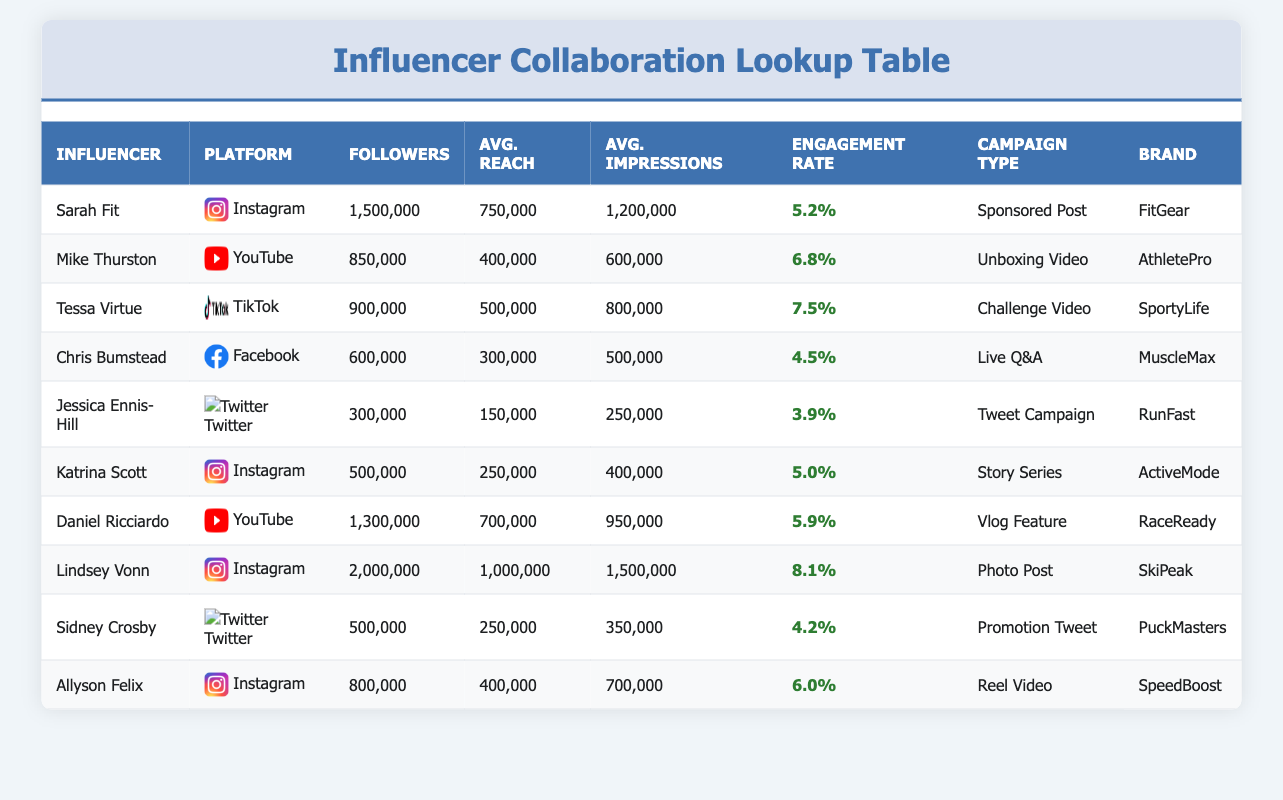What is the engagement rate of Sarah Fit? The engagement rate for Sarah Fit is listed directly in the table under the "Engagement Rate" column, showing 5.2%.
Answer: 5.2% Which influencer has the highest average impressions? By comparing the values in the "Avg. Impressions" column, Lindsey Vonn has the highest average impressions at 1,500,000.
Answer: 1,500,000 How many followers do all influencers combined have? The total number of followers can be calculated by adding up the values in the "Followers" column: 1,500,000 + 850,000 + 900,000 + 600,000 + 300,000 + 500,000 + 1,300,000 + 2,000,000 + 500,000 + 800,000 = 9,800,000. The sum is 9,800,000.
Answer: 9,800,000 Is Mike Thurston's engagement rate higher than Jessica Ennis-Hill's? Mike Thurston's engagement rate is 6.8%, while Jessica Ennis-Hill's engagement rate is 3.9%. Since 6.8% is greater than 3.9%, the answer is yes.
Answer: Yes What is the average reach of Instagram influencers based on this data? First, identify all influencers on Instagram: Sarah Fit, Katrina Scott, and Lindsey Vonn. Their average reach values are 750,000, 250,000, and 1,000,000, respectively. Sum these reach values: 750,000 + 250,000 + 1,000,000 = 2,000,000. There are 3 influencers, so divide by 3: 2,000,000 / 3 = 666,667.
Answer: 666,667 Which campaign type had the highest average reach, and what was the value? Calculate the average reach for each campaign type, looking at the corresponding values in the "Avg. Reach" column. The campaign types include: Sponsored Post (750,000), Unboxing Video (400,000), Challenge Video (500,000), Live Q&A (300,000), Tweet Campaign (150,000), Story Series (250,000), Vlog Feature (700,000), Photo Post (1,000,000), Promotion Tweet (250,000), and Reel Video (400,000). The highest average reach is from the Photo Post campaign type at 1,000,000.
Answer: Photo Post, 1,000,000 How many influencers have an engagement rate above 6%? Checking each influencer's engagement rate, we have: Sarah Fit (5.2%), Mike Thurston (6.8%), Tessa Virtue (7.5%), Chris Bumstead (4.5%), Jessica Ennis-Hill (3.9%), Katrina Scott (5.0%), Daniel Ricciardo (5.9%), Lindsey Vonn (8.1%), Sidney Crosby (4.2%), and Allyson Felix (6.0%). The influencers above 6% are Mike Thurston, Tessa Virtue, and Lindsey Vonn, totaling 3 influencers.
Answer: 3 Is the average impressions for "Live Q&A" higher than that for "Reel Video"? The average impressions for Live Q&A is 500,000, and for Reel Video, it is 700,000. Since 500,000 is less than 700,000, the answer is no.
Answer: No 